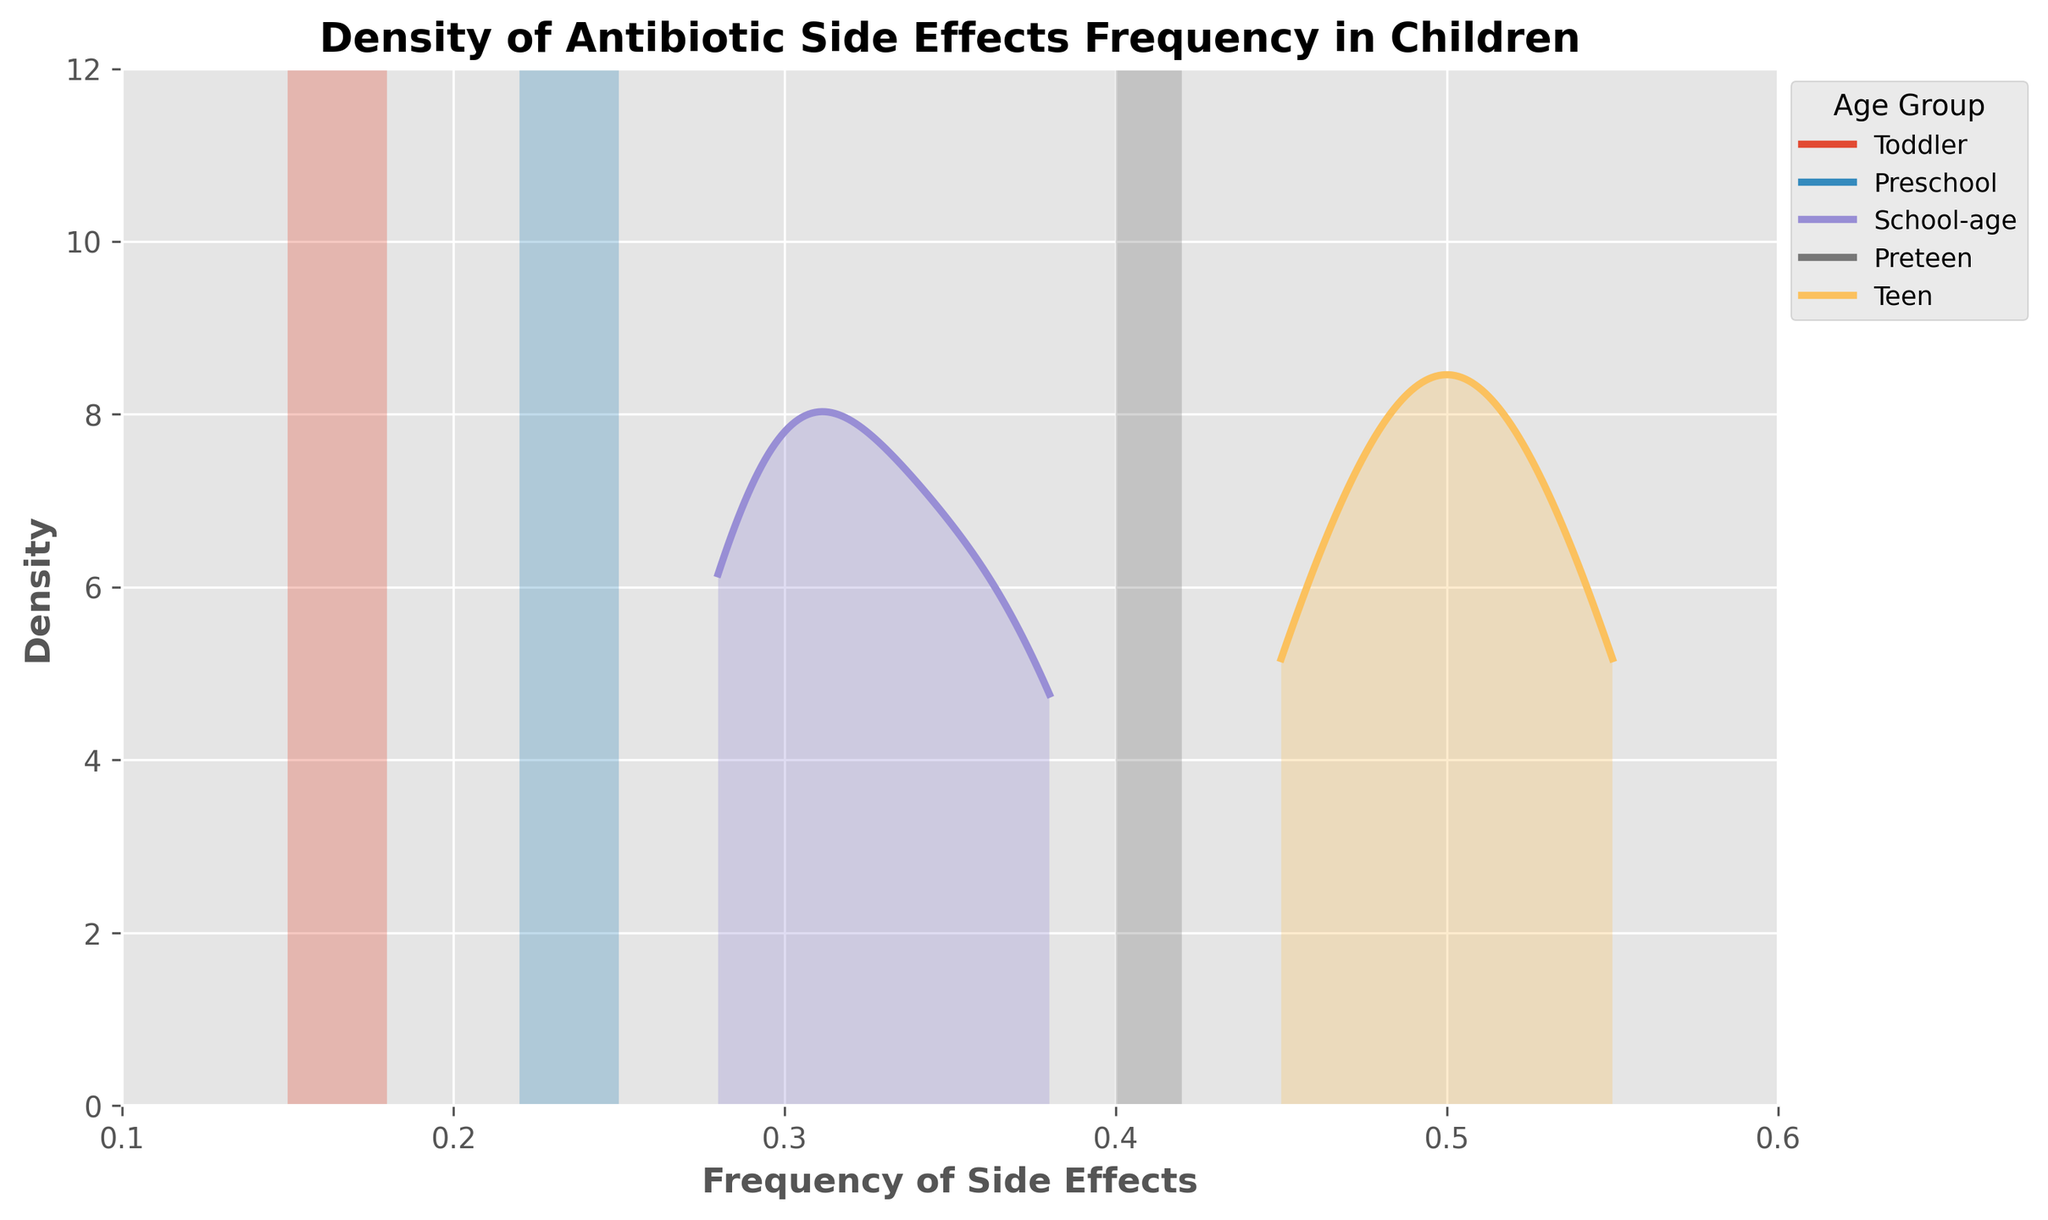What is the title of the plot? The title is displayed at the top of the plot.
Answer: Density of Antibiotic Side Effects Frequency in Children What does the x-axis represent? The x-axis label is indicated below the axis.
Answer: Frequency of Side Effects What age group does the green density curve represent? We need to look at the legend and match the green color to the respective age group.
Answer: Preschool In which age group is the maximum frequency of side effects higher, School-age or Preteen? Compare the maximum x-values for School-age and Preteen density curves.
Answer: Preteen Which age group has the widest range of frequency of side effects? Check the range on the x-axis for each age group density curve.
Answer: Teen Which density curve appears highest, indicating the most instances at a particular frequency, between Toddler and School-age? Inspect the highest peaks of the density curves for Toddler and School-age.
Answer: Toddler What is the likely frequency of side effects with the highest density for the Teen age group? Look for the peak of the density curve for the Teen age group on the x-axis.
Answer: Around 0.52 Which age group shows the lowest starting frequency of side effects? Check the minimum x-value where each age group density curve starts.
Answer: Toddler How does the density curve for Preschool compare to School-age in terms of spread and height? Compare both the spread along the x-axis and the height (peak) of the density curves.
Answer: Preschool is narrower and shorter What age group shows the least variability in the frequency of side effects? The age group with the narrowest width on the x-axis demonstrates the least variability in frequencies.
Answer: Preschool 